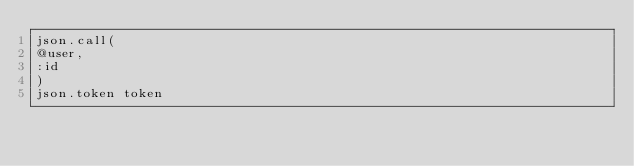<code> <loc_0><loc_0><loc_500><loc_500><_Ruby_>json.call(
@user, 
:id
)
json.token token

</code> 